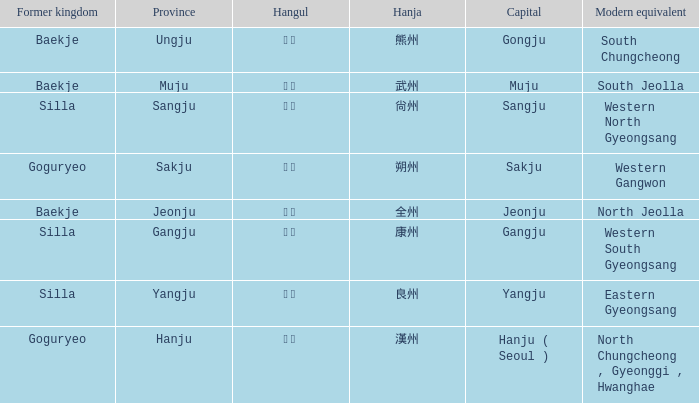What current location corresponds to the historical kingdom of "silla" denoted by the hanja 尙州? 1.0. 